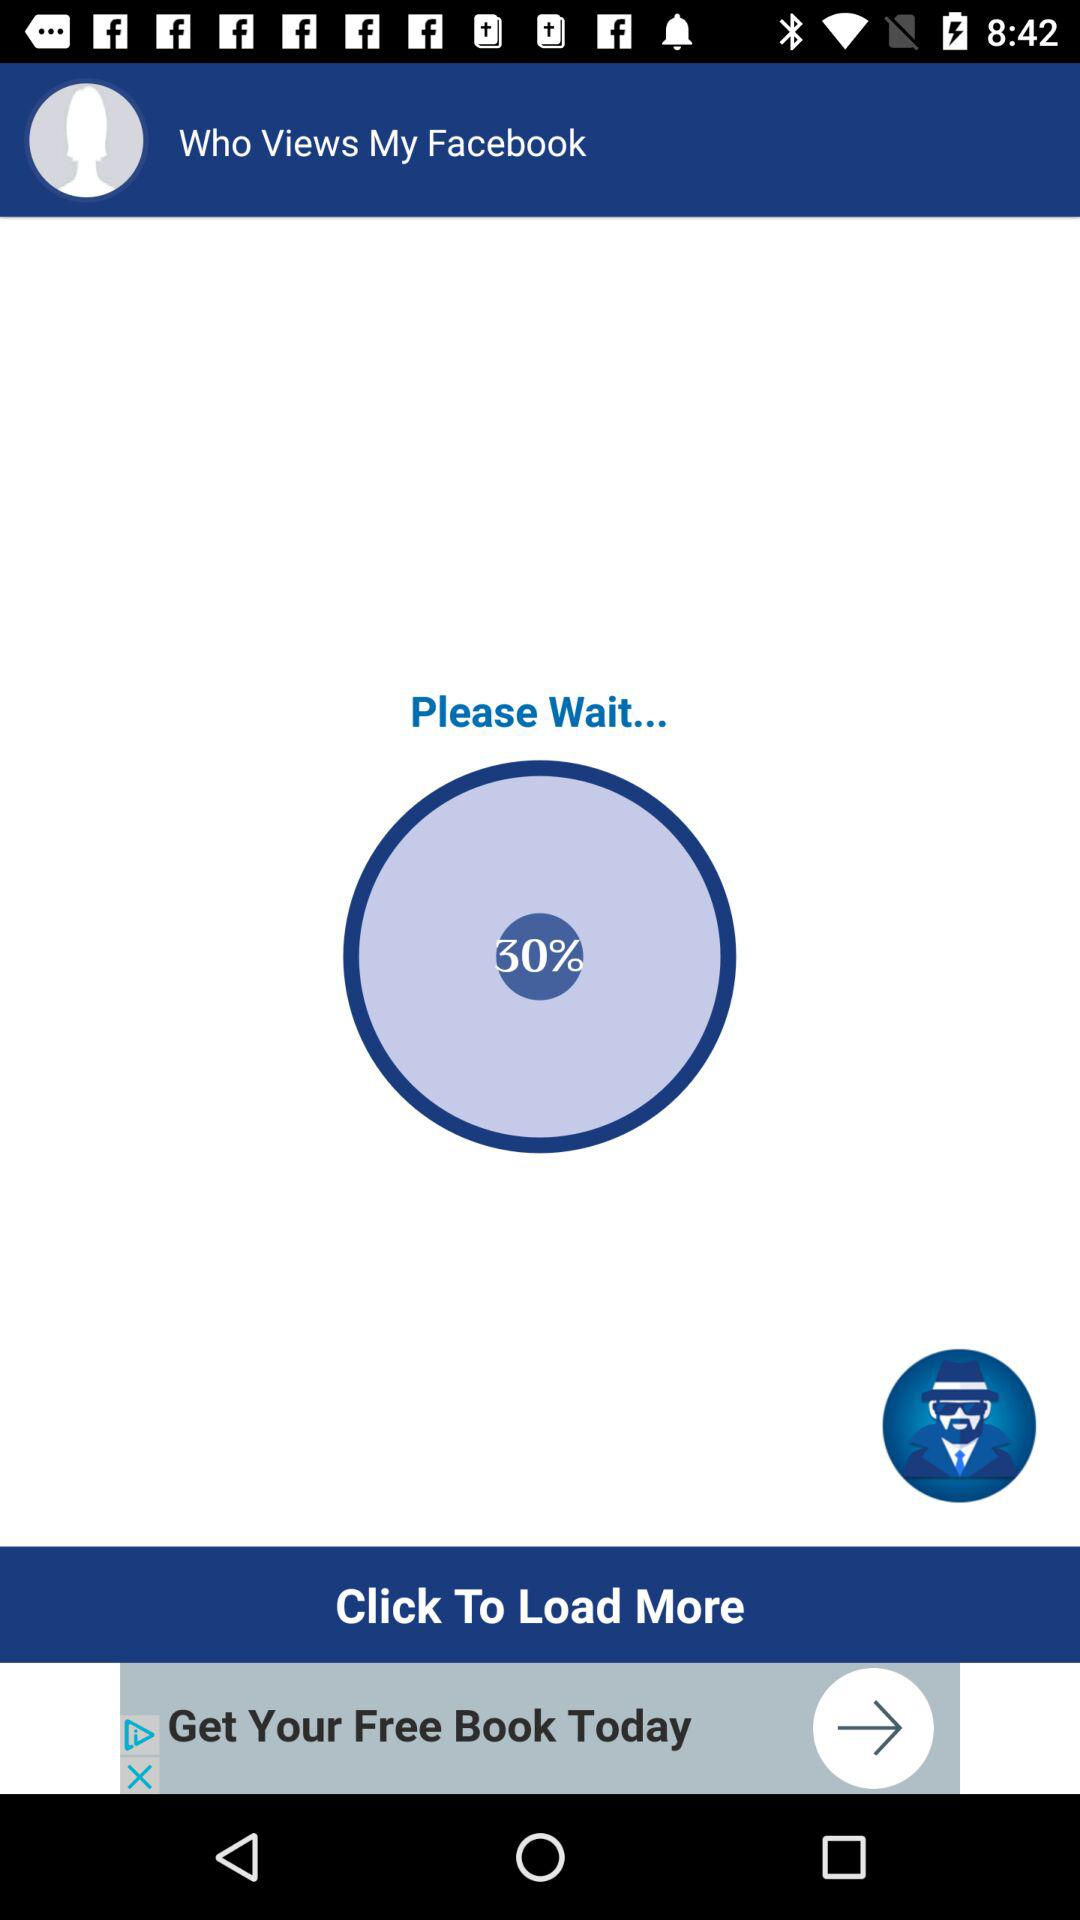What percentage is loaded? The percentage loaded is 30. 